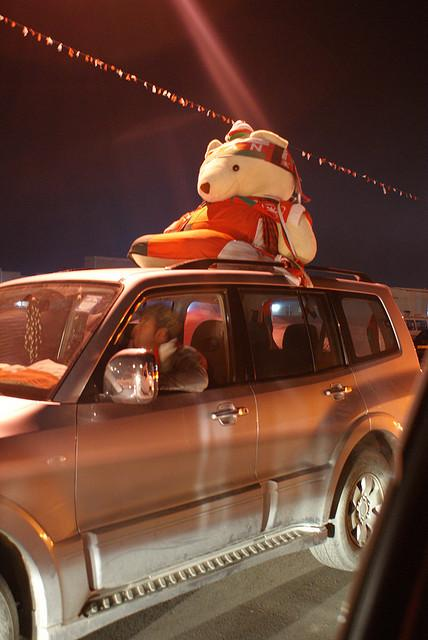What country is the scene located at? Please explain your reasoning. japan. An asian man is driving in a car. 